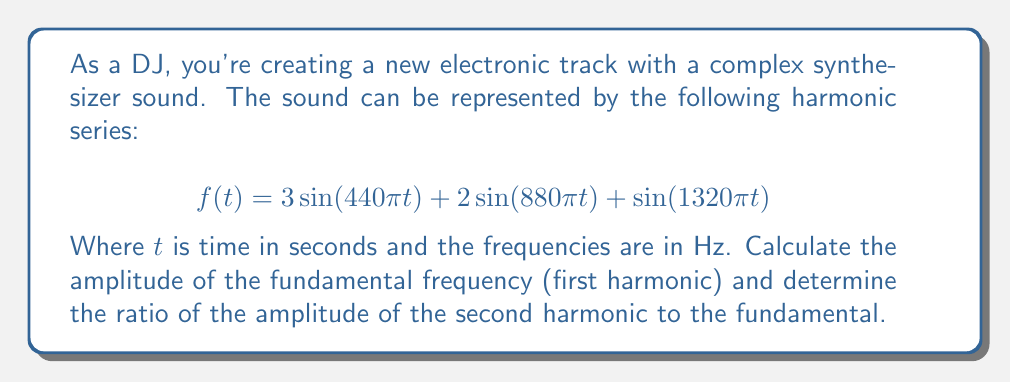Help me with this question. To solve this problem, we need to analyze the given harmonic series:

$$f(t) = 3\sin(440\pi t) + 2\sin(880\pi t) + \sin(1320\pi t)$$

1. Identify the components:
   - First harmonic (fundamental): $3\sin(440\pi t)$
   - Second harmonic: $2\sin(880\pi t)$
   - Third harmonic: $\sin(1320\pi t)$

2. Amplitude of the fundamental frequency:
   The amplitude is the coefficient of the sine function for the fundamental frequency.
   Amplitude of fundamental = 3

3. Amplitude of the second harmonic:
   The amplitude is the coefficient of the sine function for the second harmonic.
   Amplitude of second harmonic = 2

4. Calculate the ratio of the amplitude of the second harmonic to the fundamental:
   Ratio = (Amplitude of second harmonic) / (Amplitude of fundamental)
   Ratio = 2 / 3

This ratio represents the relative strength of the second harmonic compared to the fundamental, which contributes to the timbre of the synthesizer sound in your electronic track.
Answer: The amplitude of the fundamental frequency is 3, and the ratio of the amplitude of the second harmonic to the fundamental is $\frac{2}{3}$. 